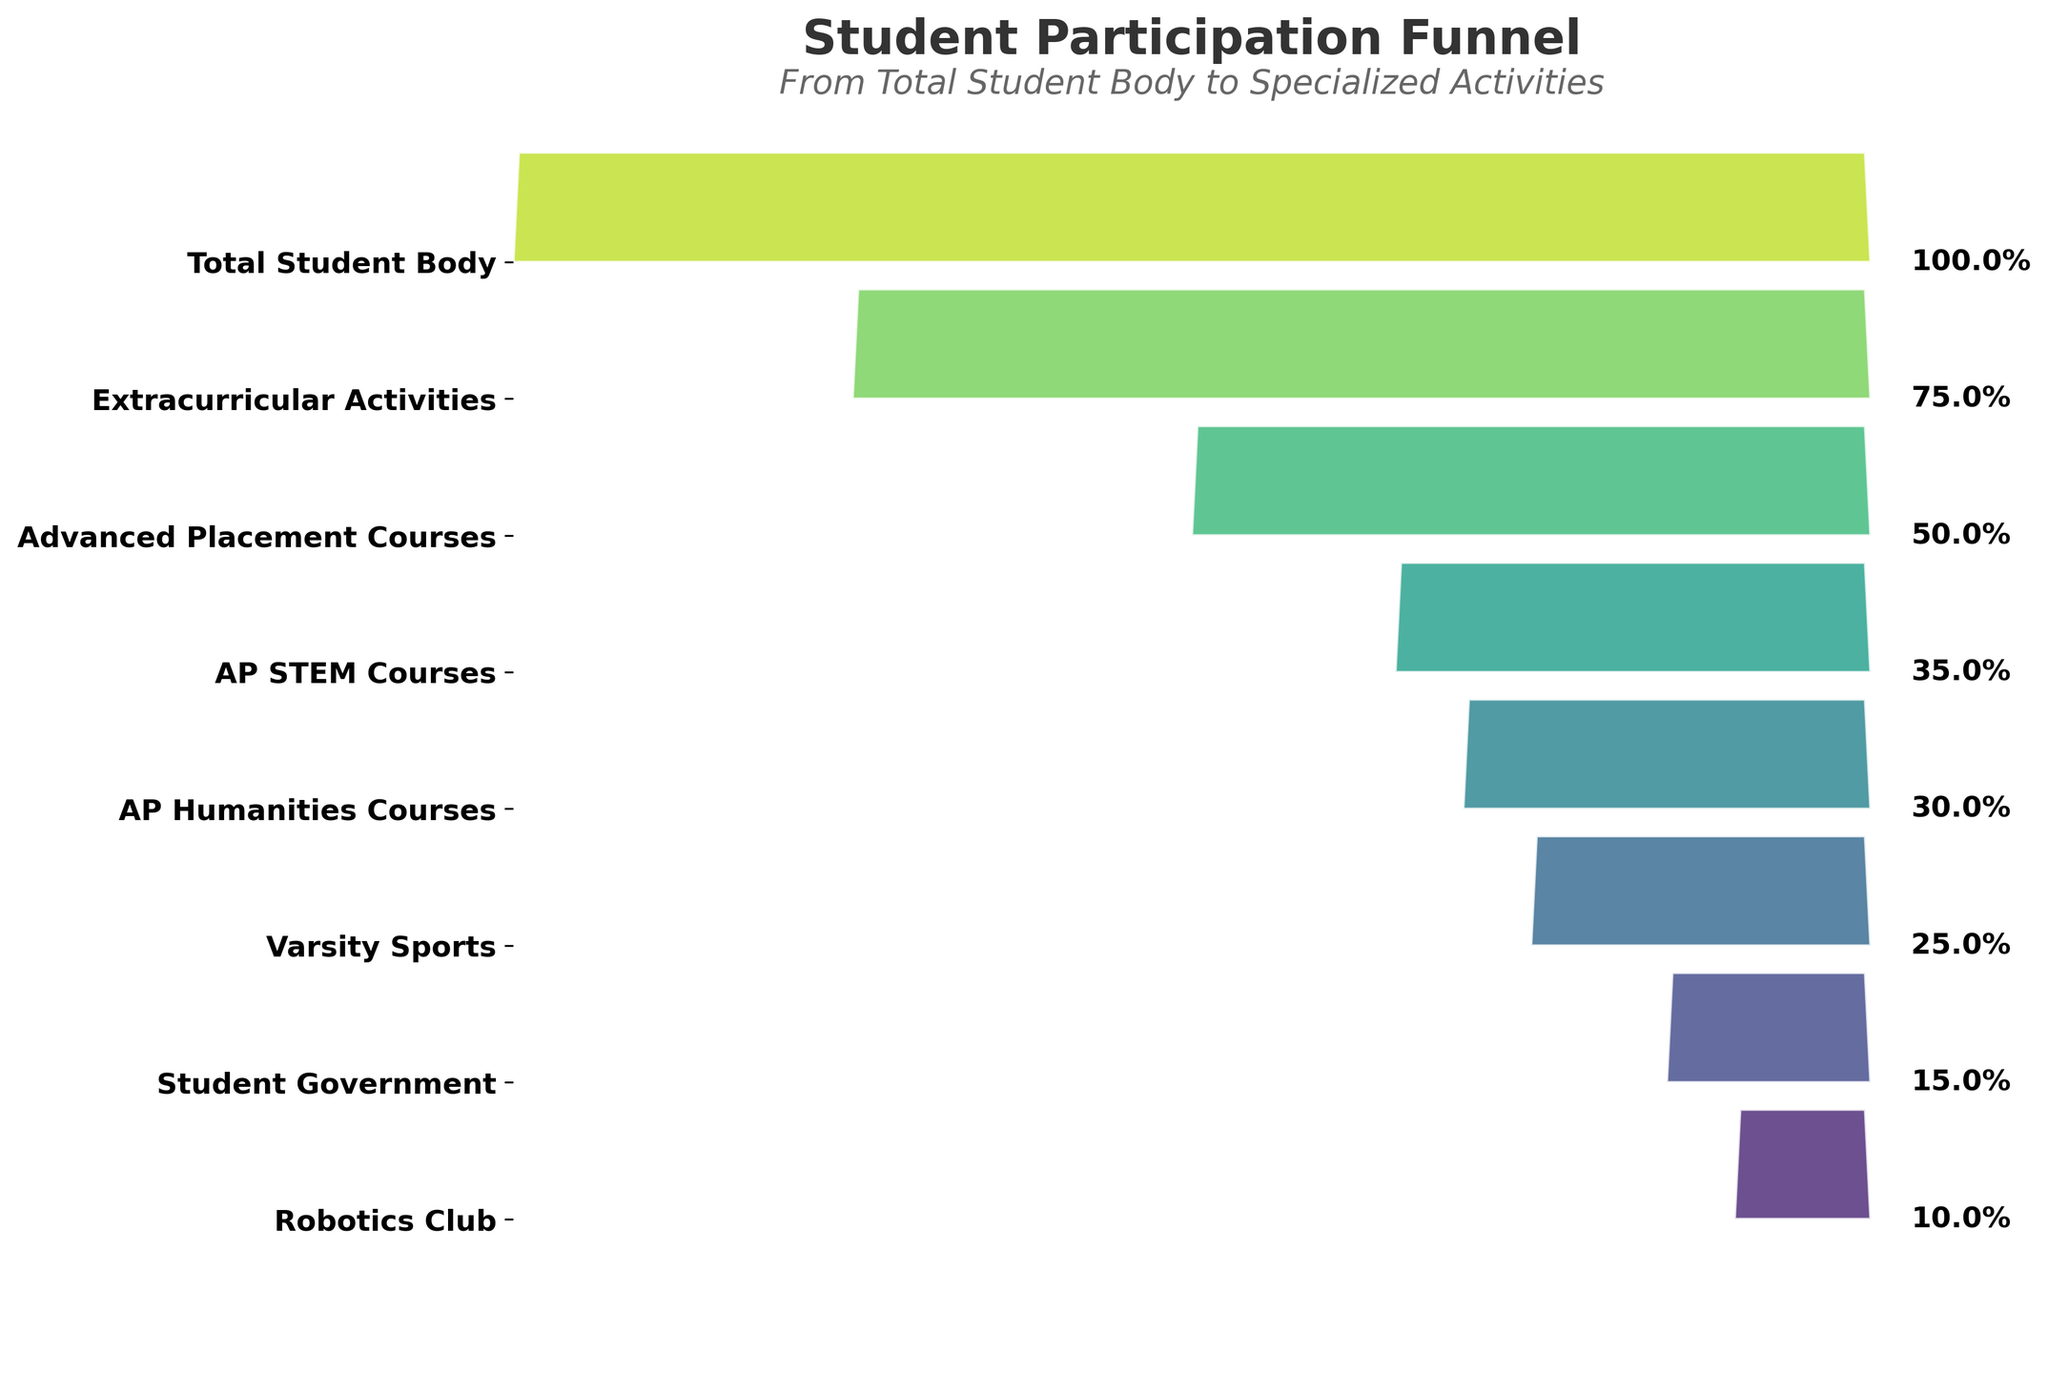What is the participation rate for Extracurricular Activities? The funnel chart lists the participation rates for each activity. The participation rate for Extracurricular Activities is displayed second from the top.
Answer: 75% Which activity has the lowest participation rate? The activity with the lowest rate will be at the narrowest part of the funnel.
Answer: Robotics Club Are there more students participating in AP Humanities Courses or Varsity Sports? The funnel chart shows participation rates for different activities. AP Humanities Courses has a rate of 30%, while Varsity Sports has a rate of 25%. So, more students participate in AP Humanities Courses.
Answer: AP Humanities Courses By how much does the participation rate in AP STEM Courses exceed that of Student Government? AP STEM Courses have a participation rate of 35%, and Student Government has 15%. Subtract the rate for Student Government from the rate for AP STEM Courses: 35% - 15%.
Answer: 20% What is the third highest participation rate shown in the funnel chart? To find the third highest rate, look at rates from highest to lowest (100%, 75%, 50%, then 35%). The third highest rate is for Advanced Placement Courses.
Answer: 50% What percentage of students participate in at least one of the listed extracurricular activities? The topmost activity, Extracurricular Activities, encompasses participation in any listed extracurriculars which is shown as 75%. This includes all listed activities under this category.
Answer: 75% How much lower is the participation rate in Robotics Club compared to AP STEM Courses? Robotics Club has a rate of 10% and AP STEM Courses has a rate of 35%. Subtract the rate for Robotics Club from the rate for AP STEM Courses: 35% - 10%.
Answer: 25% Compare the participation rates of AP STEM Courses and AP Humanities Courses. Which is higher and by how much? AP STEM Courses have a rate of 35% and AP Humanities Courses have a rate of 30%. Subtract the rate for AP Humanities Courses from the rate for AP STEM Courses: 35% - 30%.
Answer: AP STEM Courses, 5% What is the average participation rate for the AP courses listed (AP STEM Courses and AP Humanities Courses)? Add the participation rates for AP STEM Courses (35%) and AP Humanities Courses (30%), then divide by 2. (35% + 30%) / 2
Answer: 32.5% Which activity has a participation rate exactly half of the total student body? The total student body has a participation rate of 100%. The activity with a 50% participation rate is Advanced Placement Courses, which is exactly half.
Answer: Advanced Placement Courses 